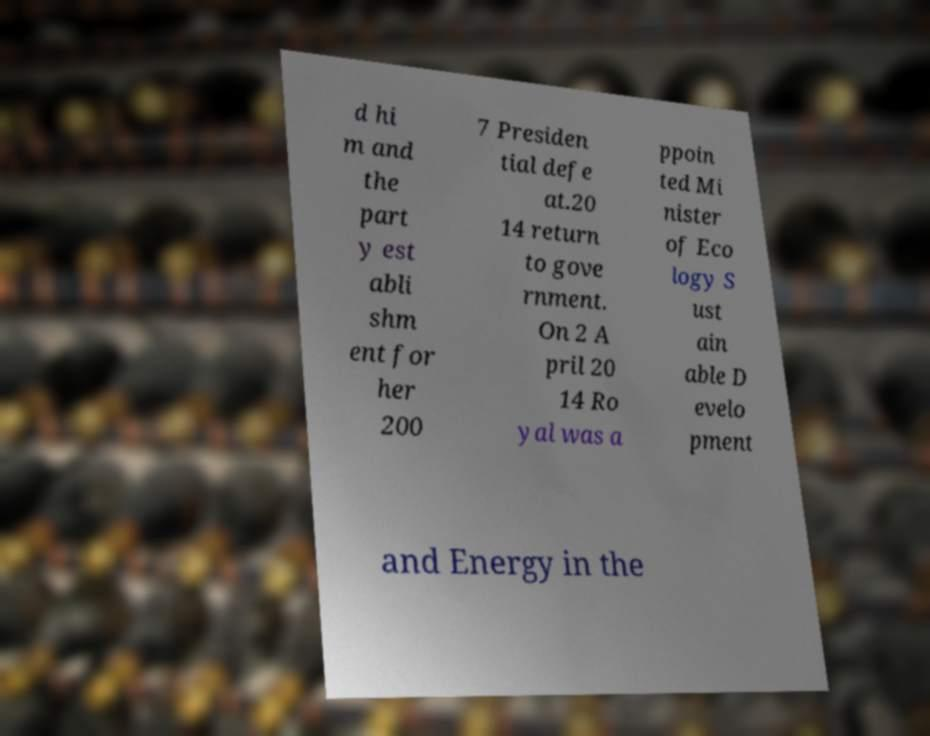Can you accurately transcribe the text from the provided image for me? d hi m and the part y est abli shm ent for her 200 7 Presiden tial defe at.20 14 return to gove rnment. On 2 A pril 20 14 Ro yal was a ppoin ted Mi nister of Eco logy S ust ain able D evelo pment and Energy in the 